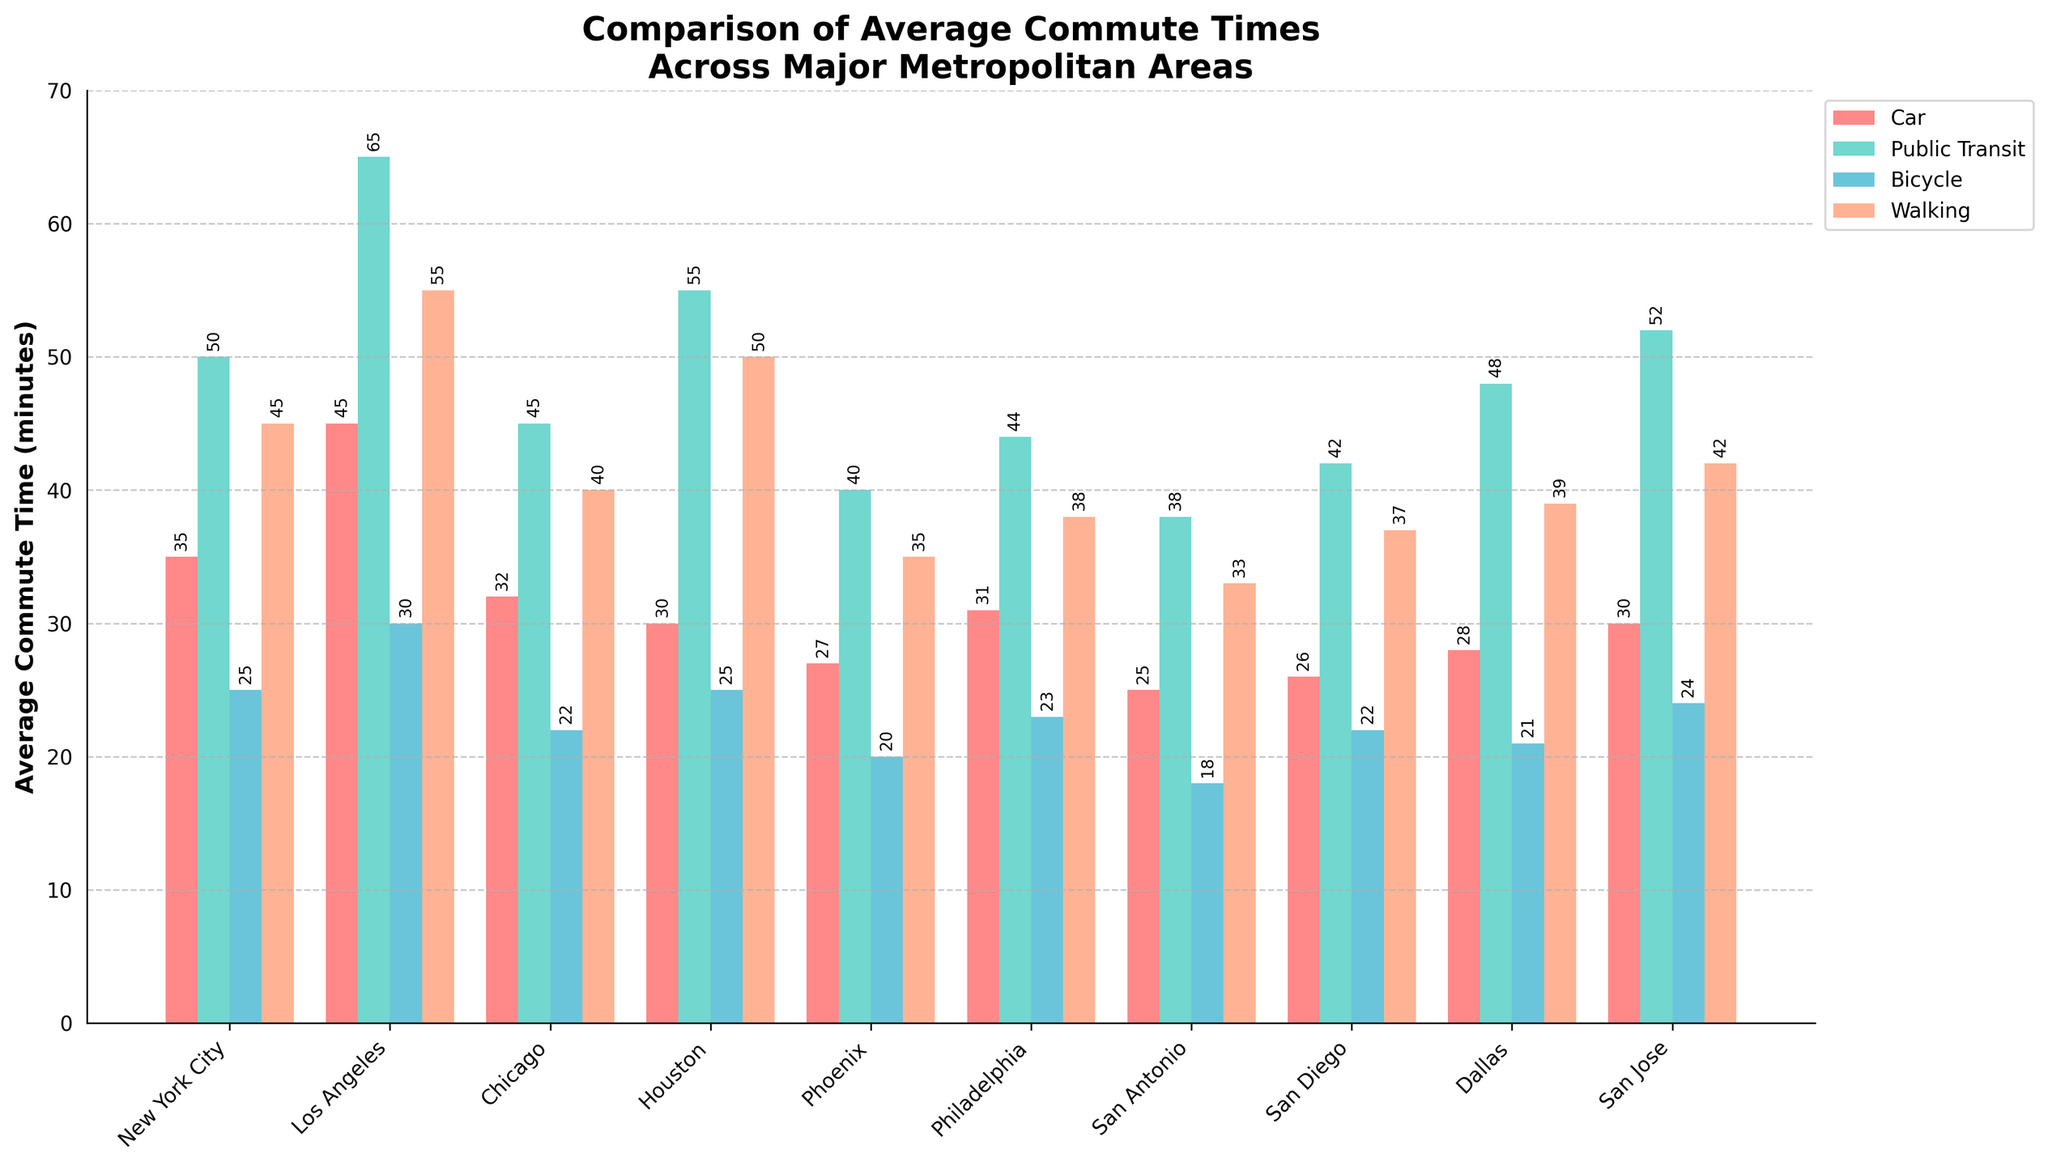what is the average commute time by car in Los Angeles and San Francisco combined? The commute times by car in Los Angeles and San Francisco are 45 and 34 minutes, respectively. The average is calculated as (45 + 34) / 2 = 79 / 2 = 39.5 minutes
Answer: 39.5 what is the difference in public transit commute times between New York City and Houston? The public transit commute time is 50 minutes for New York City and 55 minutes for Houston. The difference is 55 - 50 = 5 minutes
Answer: 5 which city has the shortest average commute time by bicycle? The city with the shortest average commute time by bicycle is Indianapolis, with 17 minutes
Answer: Indianapolis For New York City, what’s the difference between the average commute time by walking and by car? For New York City, the average commute time by walking is 45 minutes, and by car, it's 35 minutes. The difference is 45 - 35 = 10 minutes
Answer: 10 which city has the highest average commute time by walking among the top 10 cities? Among the top 10 cities, Los Angeles has the highest average commute time by walking, which is 55 minutes
Answer: Los Angeles how much longer is the average public transit commute in Los Angeles compared to Phoenix? The average public transit commute time is 65 minutes in Los Angeles and 40 minutes in Phoenix. The difference is 65 - 40 = 25 minutes
Answer: 25 which transportation method generally has the longest average commute time across the first 10 cities? Observing the bar heights, public transit generally has the longest average commute time across the first 10 cities
Answer: Public Transit Which city among the top 10 has the narrowest range of average commute times across different transportation methods? Measure the difference between the highest and lowest commute times in each city. San Diego has the narrowest range, with a range of 42 (Public Transit) - 22 (Bicycle) = 20 minutes
Answer: San Diego in chicago, what’s the difference between the highest and lowest average commute times across the different transportation methods? In Chicago, the highest average commute time is by public transit at 45 minutes, and the lowest is by bicycle at 22 minutes. The difference is 45 - 22 = 23 minutes
Answer: 23 what is the average commute time by walking for all top 10 cities combined? Sum the walking commute times for the top 10 cities (45+55+40+50+35+38+33+37+39+42) = 414 minutes. Divide this by 10 cities to get the average: 414 / 10 = 41.4 minutes
Answer: 41.4 